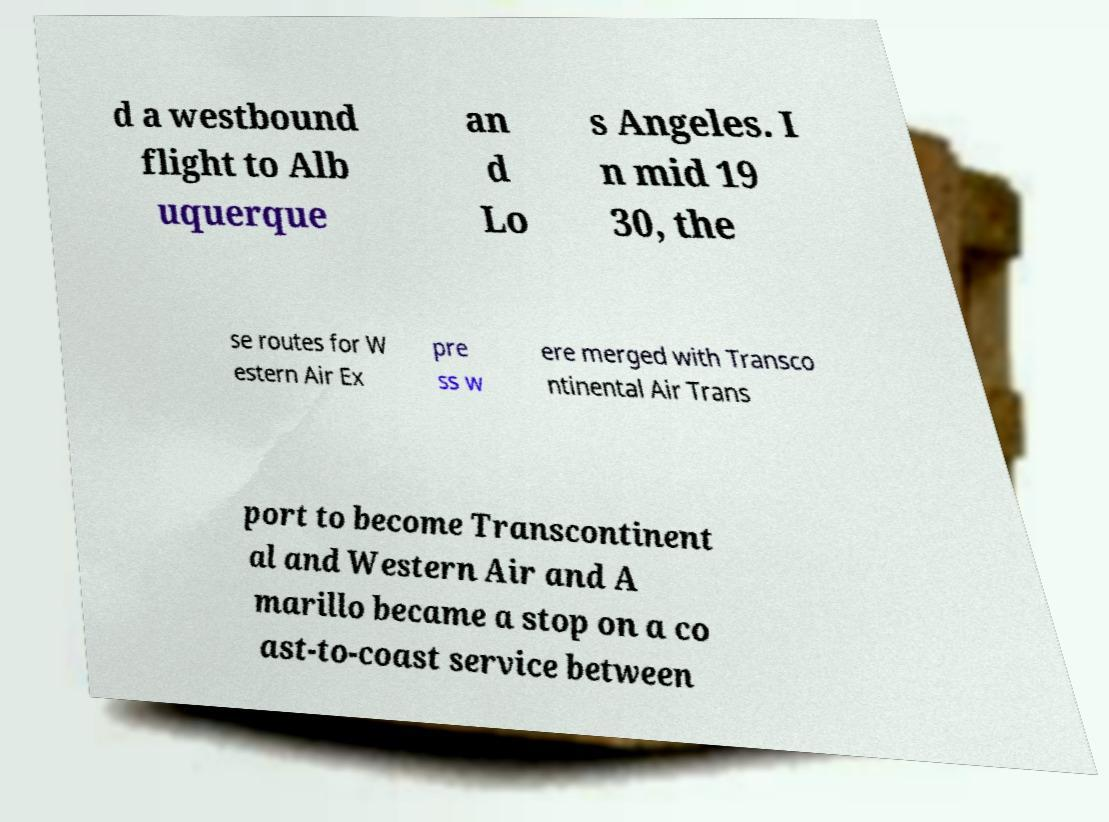Could you extract and type out the text from this image? d a westbound flight to Alb uquerque an d Lo s Angeles. I n mid 19 30, the se routes for W estern Air Ex pre ss w ere merged with Transco ntinental Air Trans port to become Transcontinent al and Western Air and A marillo became a stop on a co ast-to-coast service between 